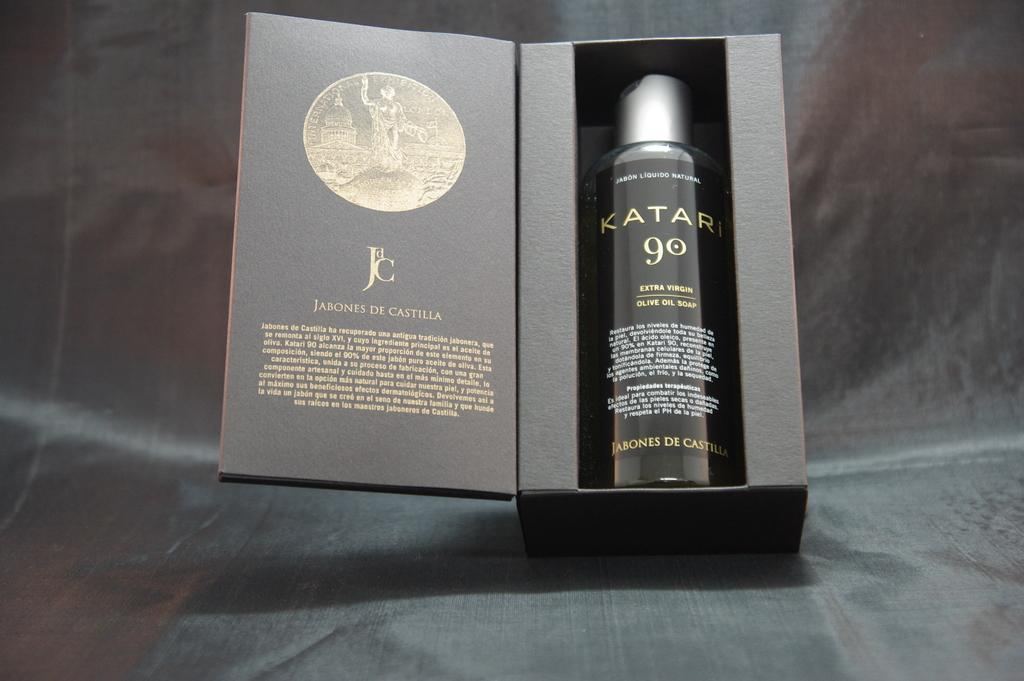<image>
Share a concise interpretation of the image provided. A box with a bottle of Katari 90 inside of ir 